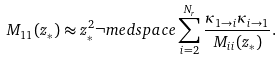<formula> <loc_0><loc_0><loc_500><loc_500>M _ { 1 1 } ( z _ { * } ) \approx z _ { * } ^ { 2 } \neg m e d s p a c e \sum _ { i = 2 } ^ { N _ { r } } \frac { \kappa _ { 1 \rightarrow i } \kappa _ { i \rightarrow 1 } } { M _ { i i } ( z _ { * } ) } .</formula> 